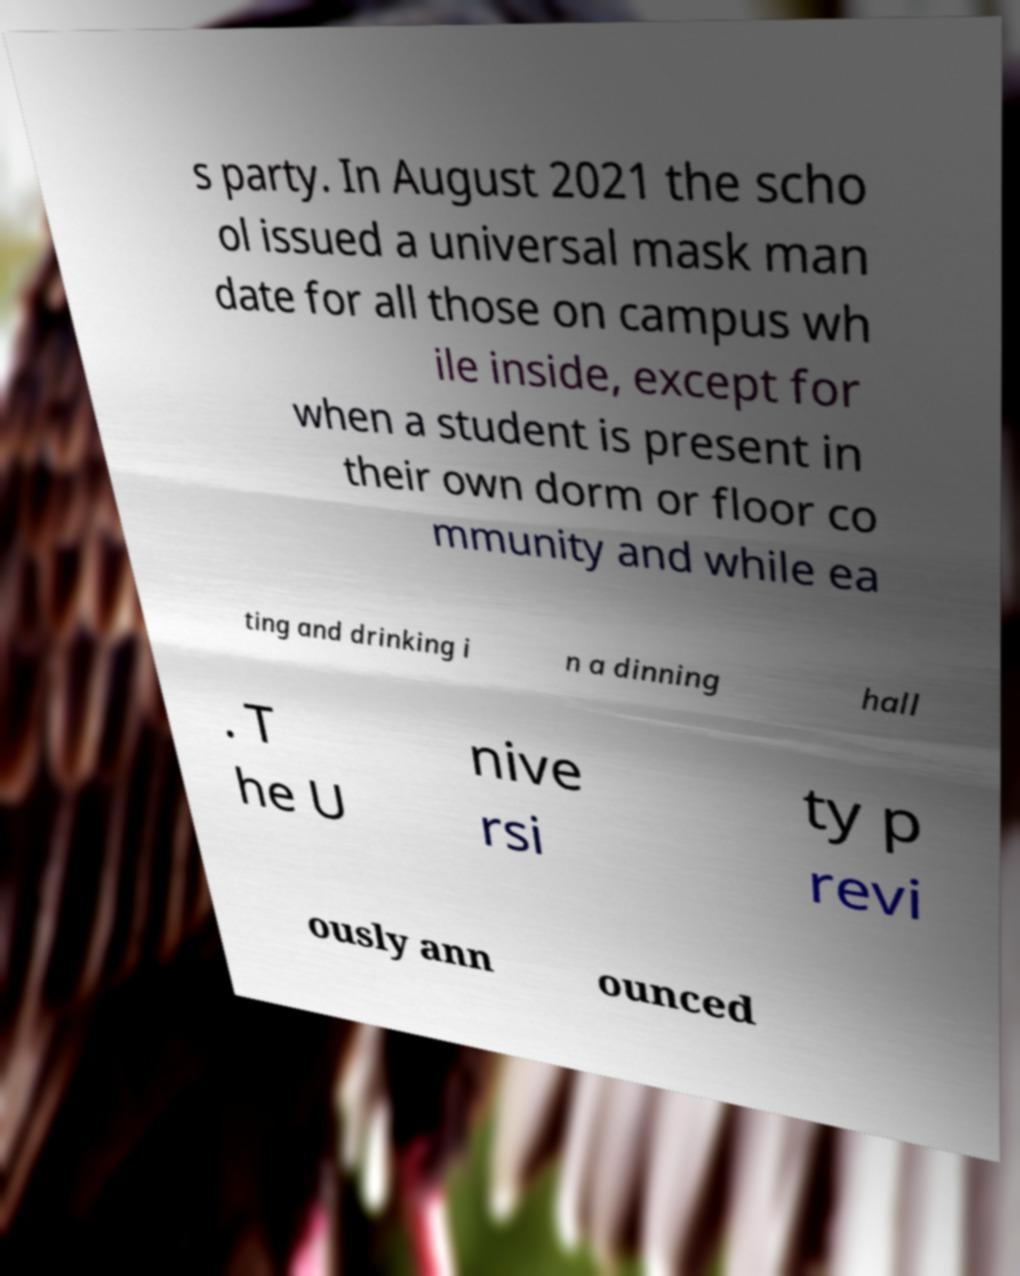What messages or text are displayed in this image? I need them in a readable, typed format. s party. In August 2021 the scho ol issued a universal mask man date for all those on campus wh ile inside, except for when a student is present in their own dorm or floor co mmunity and while ea ting and drinking i n a dinning hall . T he U nive rsi ty p revi ously ann ounced 